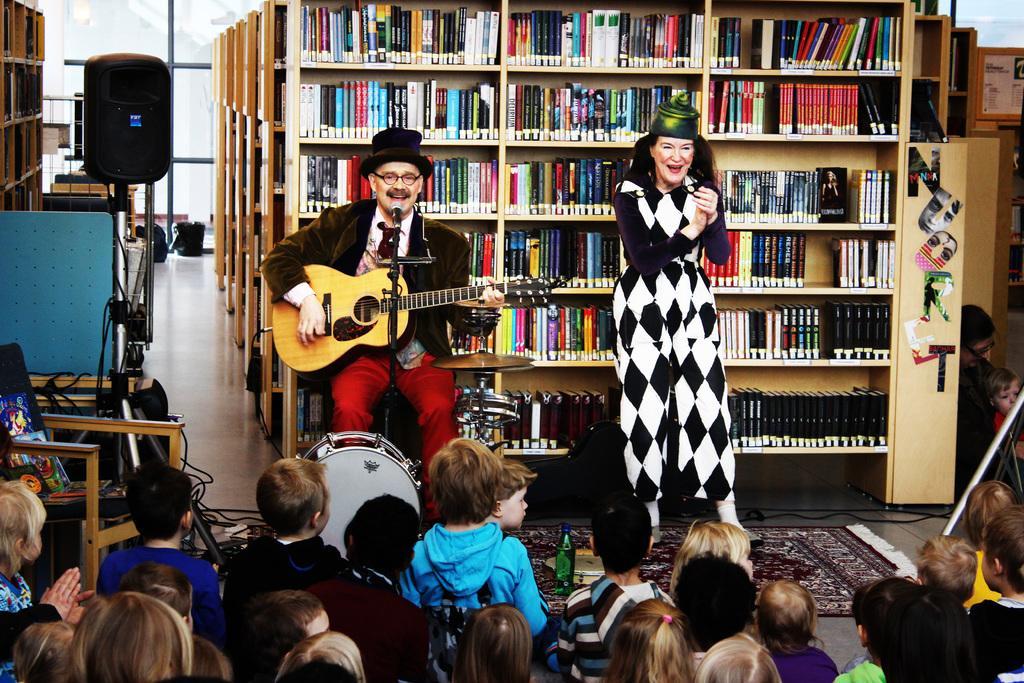Could you give a brief overview of what you see in this image? In the image there a guy playing guitar and singing on mic in the front and beside him there is a lady clapping and in front there are many kids sat. 